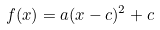Convert formula to latex. <formula><loc_0><loc_0><loc_500><loc_500>f ( x ) = a ( x - c ) ^ { 2 } + c</formula> 